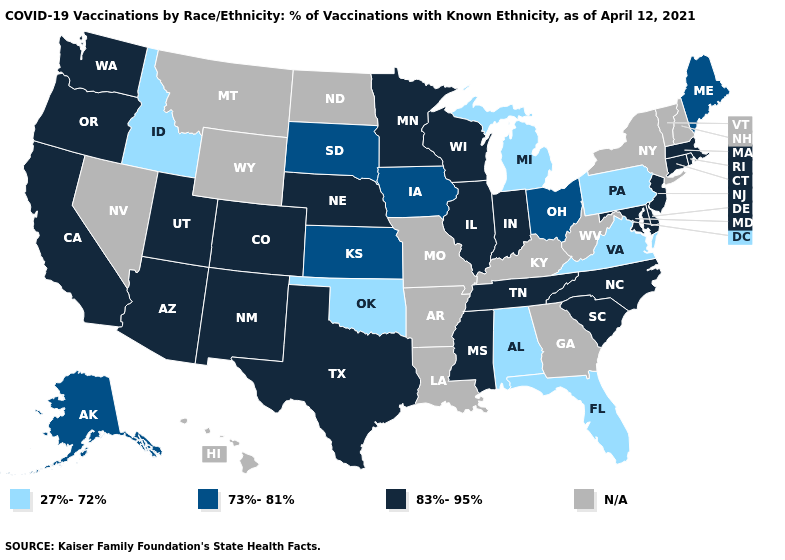What is the value of Pennsylvania?
Keep it brief. 27%-72%. Which states have the highest value in the USA?
Quick response, please. Arizona, California, Colorado, Connecticut, Delaware, Illinois, Indiana, Maryland, Massachusetts, Minnesota, Mississippi, Nebraska, New Jersey, New Mexico, North Carolina, Oregon, Rhode Island, South Carolina, Tennessee, Texas, Utah, Washington, Wisconsin. Does the map have missing data?
Concise answer only. Yes. Name the states that have a value in the range 27%-72%?
Give a very brief answer. Alabama, Florida, Idaho, Michigan, Oklahoma, Pennsylvania, Virginia. Does the first symbol in the legend represent the smallest category?
Write a very short answer. Yes. What is the value of Tennessee?
Be succinct. 83%-95%. Name the states that have a value in the range 83%-95%?
Be succinct. Arizona, California, Colorado, Connecticut, Delaware, Illinois, Indiana, Maryland, Massachusetts, Minnesota, Mississippi, Nebraska, New Jersey, New Mexico, North Carolina, Oregon, Rhode Island, South Carolina, Tennessee, Texas, Utah, Washington, Wisconsin. Name the states that have a value in the range 27%-72%?
Be succinct. Alabama, Florida, Idaho, Michigan, Oklahoma, Pennsylvania, Virginia. Does Washington have the highest value in the USA?
Keep it brief. Yes. Which states have the highest value in the USA?
Quick response, please. Arizona, California, Colorado, Connecticut, Delaware, Illinois, Indiana, Maryland, Massachusetts, Minnesota, Mississippi, Nebraska, New Jersey, New Mexico, North Carolina, Oregon, Rhode Island, South Carolina, Tennessee, Texas, Utah, Washington, Wisconsin. What is the lowest value in the Northeast?
Short answer required. 27%-72%. Does Ohio have the highest value in the MidWest?
Keep it brief. No. 